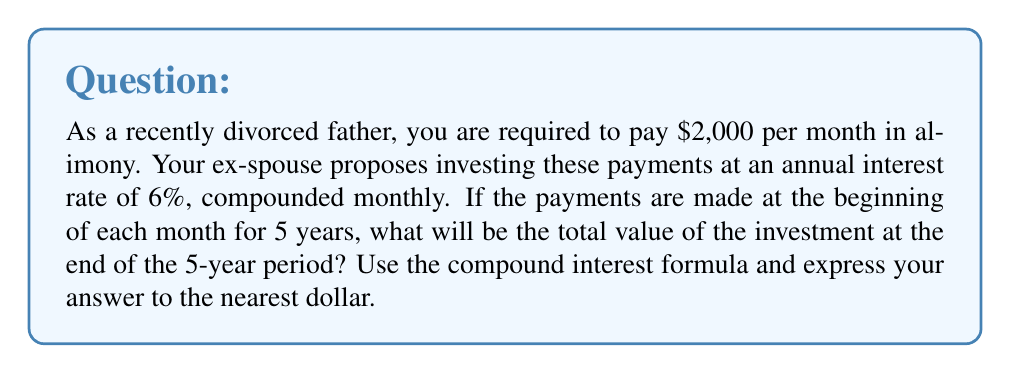Could you help me with this problem? To solve this problem, we'll use the compound interest formula for regular payments:

$$A = P \cdot \frac{(1 + r)^n - 1}{r} \cdot (1 + r)$$

Where:
$A$ = Final amount
$P$ = Regular payment amount
$r$ = Interest rate per compounding period
$n$ = Number of compounding periods

Given:
- Monthly payment: $P = \$2,000$
- Annual interest rate: 6%
- Compounding: Monthly
- Duration: 5 years

Step 1: Calculate the monthly interest rate
$$r = \frac{6\%}{12} = 0.005 \text{ or } 0.5\% \text{ per month}$$

Step 2: Calculate the number of compounding periods
$$n = 5 \text{ years} \times 12 \text{ months} = 60 \text{ periods}$$

Step 3: Apply the compound interest formula
$$\begin{aligned}
A &= 2000 \cdot \frac{(1 + 0.005)^{60} - 1}{0.005} \cdot (1 + 0.005) \\
&= 2000 \cdot \frac{1.348855 - 1}{0.005} \cdot 1.005 \\
&= 2000 \cdot 69.771 \cdot 1.005 \\
&= 140,236.86
\end{aligned}$$

Step 4: Round to the nearest dollar
$$A \approx \$140,237$$
Answer: $140,237 